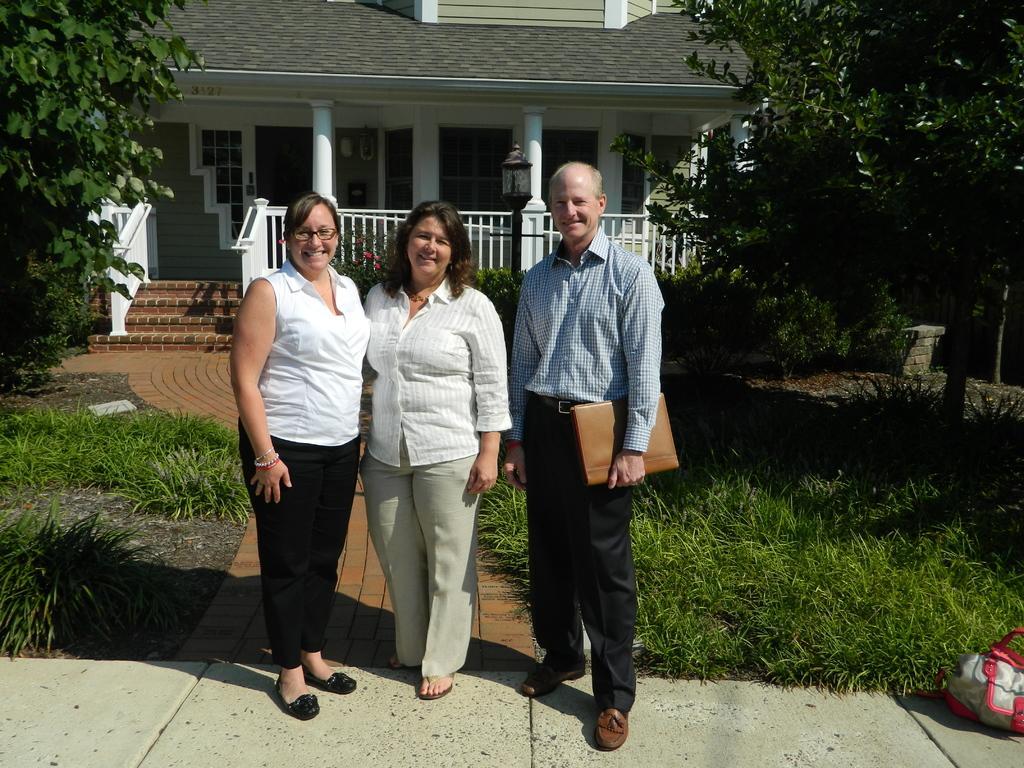Please provide a concise description of this image. There are three persons standing. Person on the left is holding something in the hand. On the ground there is grass. In the back there is a building with windows, pillars and steps with railings. Also there is a light pole. On the sides there are trees. 